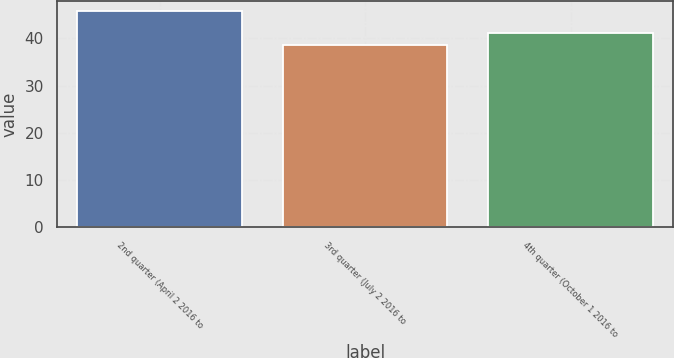Convert chart. <chart><loc_0><loc_0><loc_500><loc_500><bar_chart><fcel>2nd quarter (April 2 2016 to<fcel>3rd quarter (July 2 2016 to<fcel>4th quarter (October 1 2016 to<nl><fcel>45.71<fcel>38.5<fcel>41.18<nl></chart> 